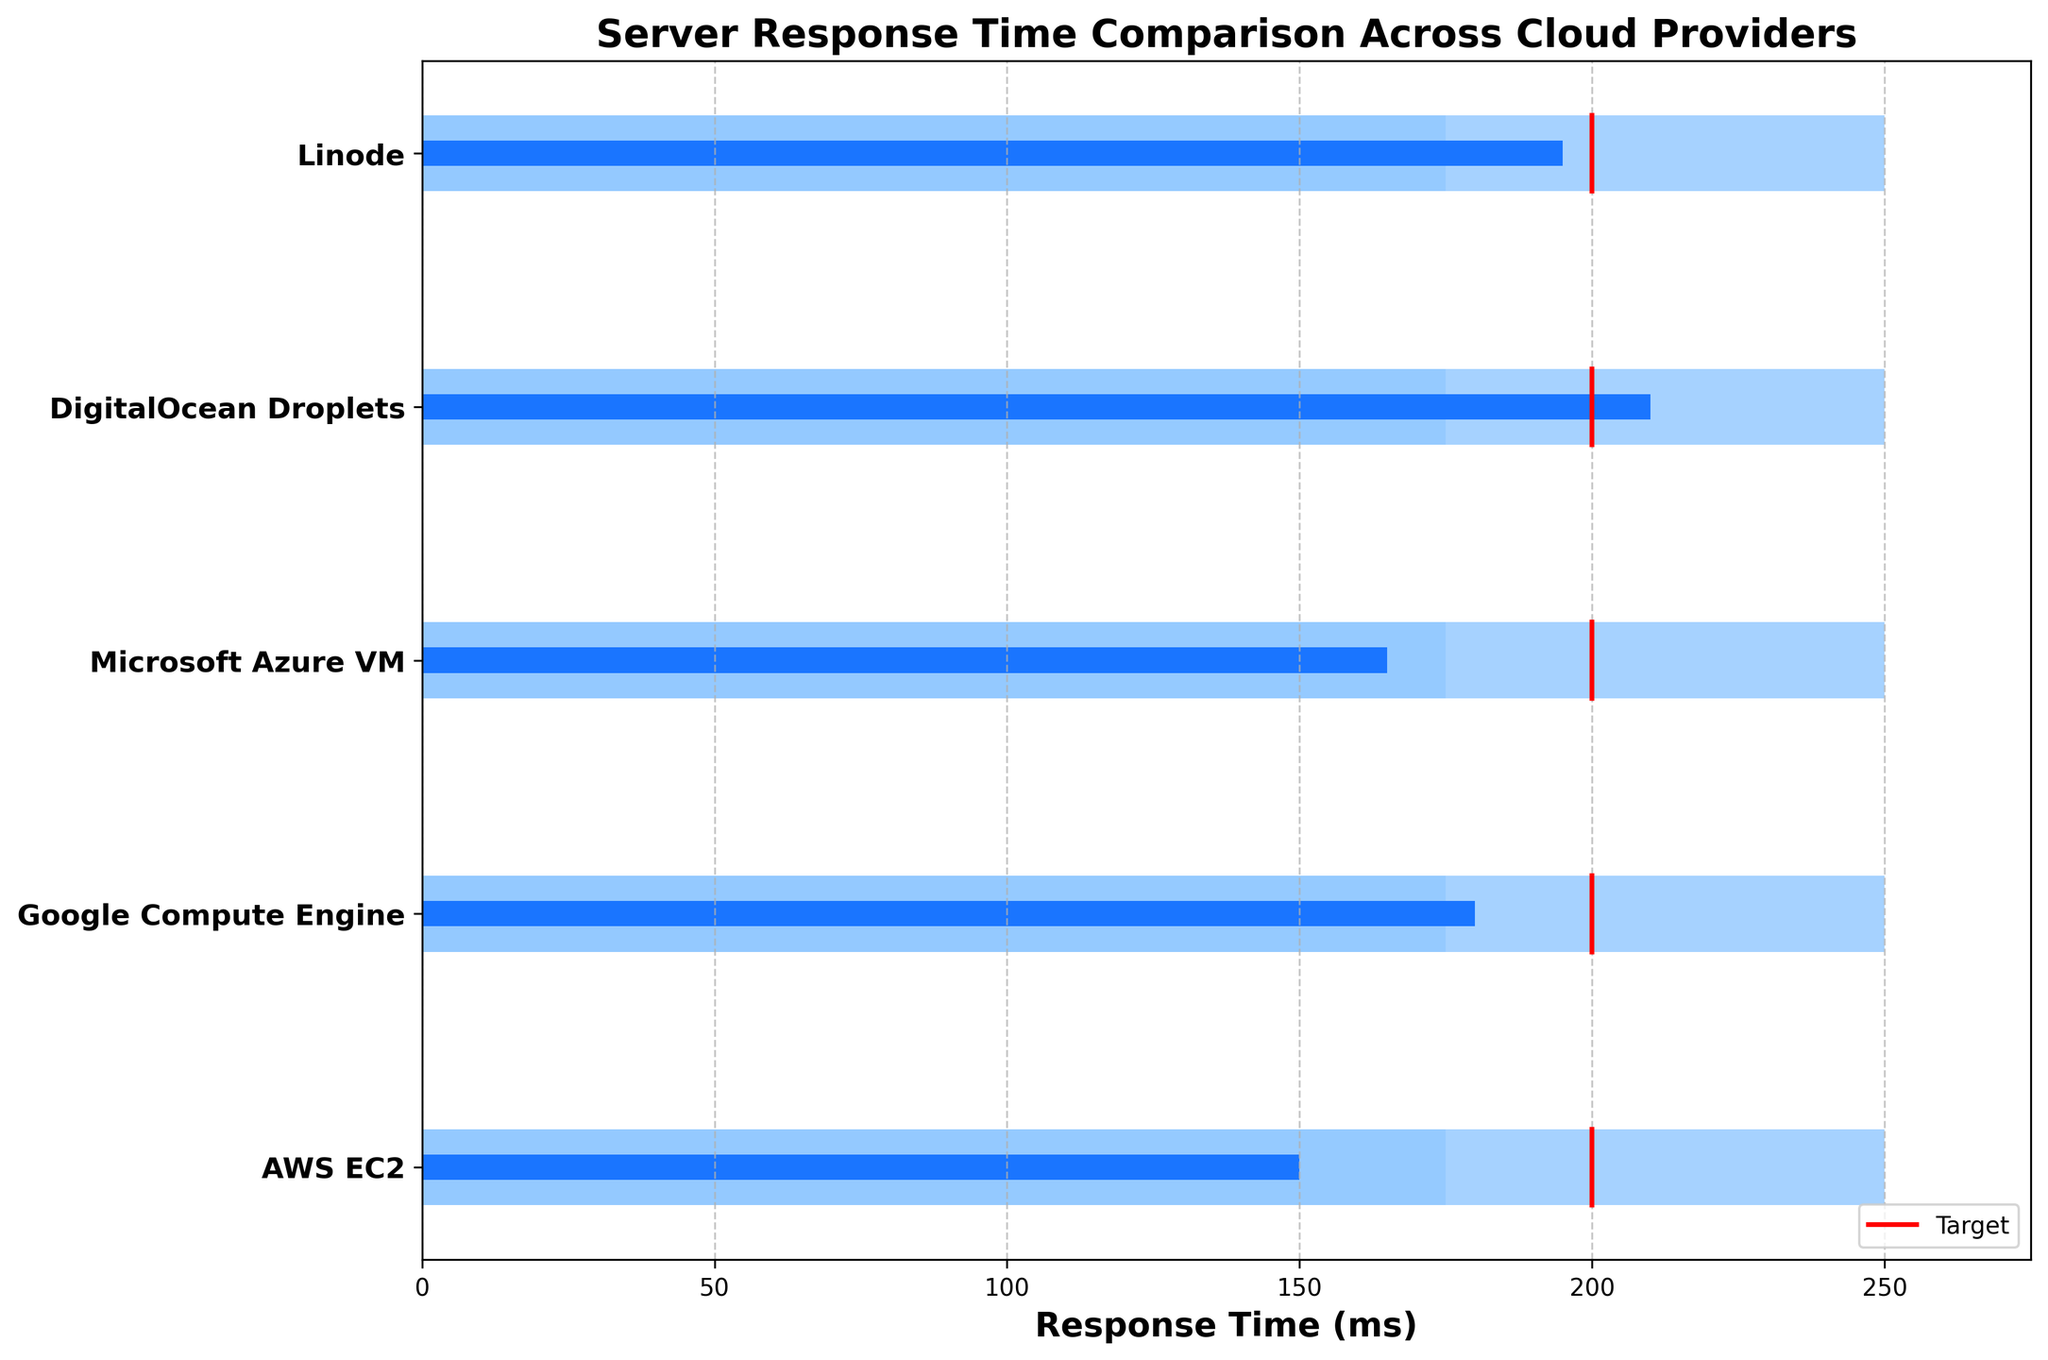How many cloud providers are compared in the figure? The figure lists the categories as AWS EC2, Google Compute Engine, Microsoft Azure VM, DigitalOcean Droplets, and Linode. Counting these, there are 5 cloud providers.
Answer: 5 What is the target response time for all cloud providers? By looking at the plot, it shows a red line for the target response time at the same value for all cloud providers. This red line is at the 200 ms mark, so the target is 200 ms for each provider.
Answer: 200 ms Which cloud provider has the highest actual response time? From the figure, comparing the blue bars representing the actual response time for each provider, DigitalOcean Droplets has the highest bar at 210 ms.
Answer: DigitalOcean Droplets Which cloud provider's actual response time exceeds the target by the largest margin? To find this, subtract the target response time (200 ms) from the actual response time for each cloud provider. DigitalOcean Droplets has an actual response time of 210 ms. Thus, 210 - 200 = 10 ms, which is the largest margin exceeding the target.
Answer: DigitalOcean Droplets How does Microsoft Azure VM's actual response time compare to AWS EC2's actual response time? From the figure, Microsoft Azure VM has an actual response time of 165 ms, while AWS EC2 has 150 ms. Comparing these, 165 ms is greater than 150 ms.
Answer: Microsoft Azure VM is 15 ms greater than AWS EC2 What are the ranges represented by different background colors in the figure? The figure shows three background color ranges for each bar: light blue (0-100 ms), medium blue (100-175 ms), and dark blue (175-250 ms).
Answer: 0-250 ms in three sections Which cloud providers fall within the best performance range (0-100 ms)? Observing the blue bars for actual response times and comparing them against the first (light blue) range, no provider falls within the 0-100 ms range in the figure.
Answer: None Is Linode's actual response time above or below the target? Linode's actual response time is 195 ms, and the target is 200 ms. 195 ms is below 200 ms.
Answer: Below What is the difference between Google Compute Engine's actual response time and the set target? Google Compute Engine has an actual response time of 180 ms. The target is 200 ms. The difference is 200 - 180 = 20 ms.
Answer: 20 ms Is there any cloud provider that exactly meets the target response time? Reviewing each actual response time bar and their alignment with the target line at 200 ms, none of the providers exactly align with this target.
Answer: No 